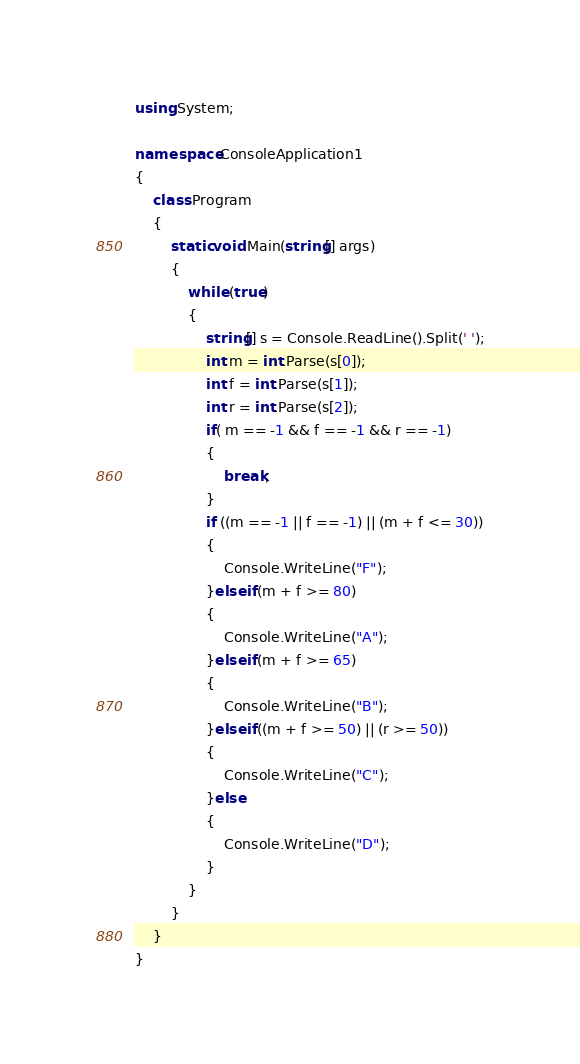<code> <loc_0><loc_0><loc_500><loc_500><_C#_>using System;

namespace ConsoleApplication1
{
    class Program
    {
        static void Main(string[] args)
        {
            while (true)
            {
                string[] s = Console.ReadLine().Split(' ');
                int m = int.Parse(s[0]);
                int f = int.Parse(s[1]);
                int r = int.Parse(s[2]);
                if( m == -1 && f == -1 && r == -1)
                {
                    break;
                }
                if ((m == -1 || f == -1) || (m + f <= 30))
                {
                    Console.WriteLine("F");
                }else if(m + f >= 80)
                {
                    Console.WriteLine("A");
                }else if(m + f >= 65)
                {
                    Console.WriteLine("B");
                }else if((m + f >= 50) || (r >= 50))
                {
                    Console.WriteLine("C");
                }else
                {
                    Console.WriteLine("D");
                }
            }
        }
    }
}</code> 